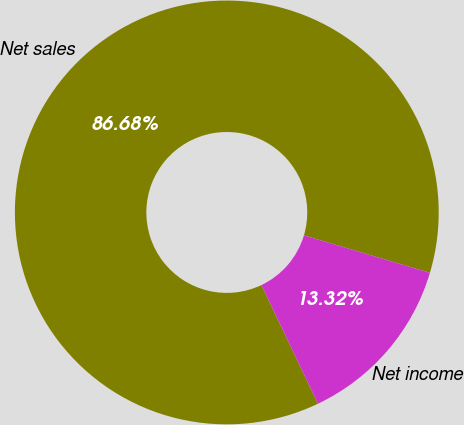<chart> <loc_0><loc_0><loc_500><loc_500><pie_chart><fcel>Net sales<fcel>Net income<nl><fcel>86.68%<fcel>13.32%<nl></chart> 